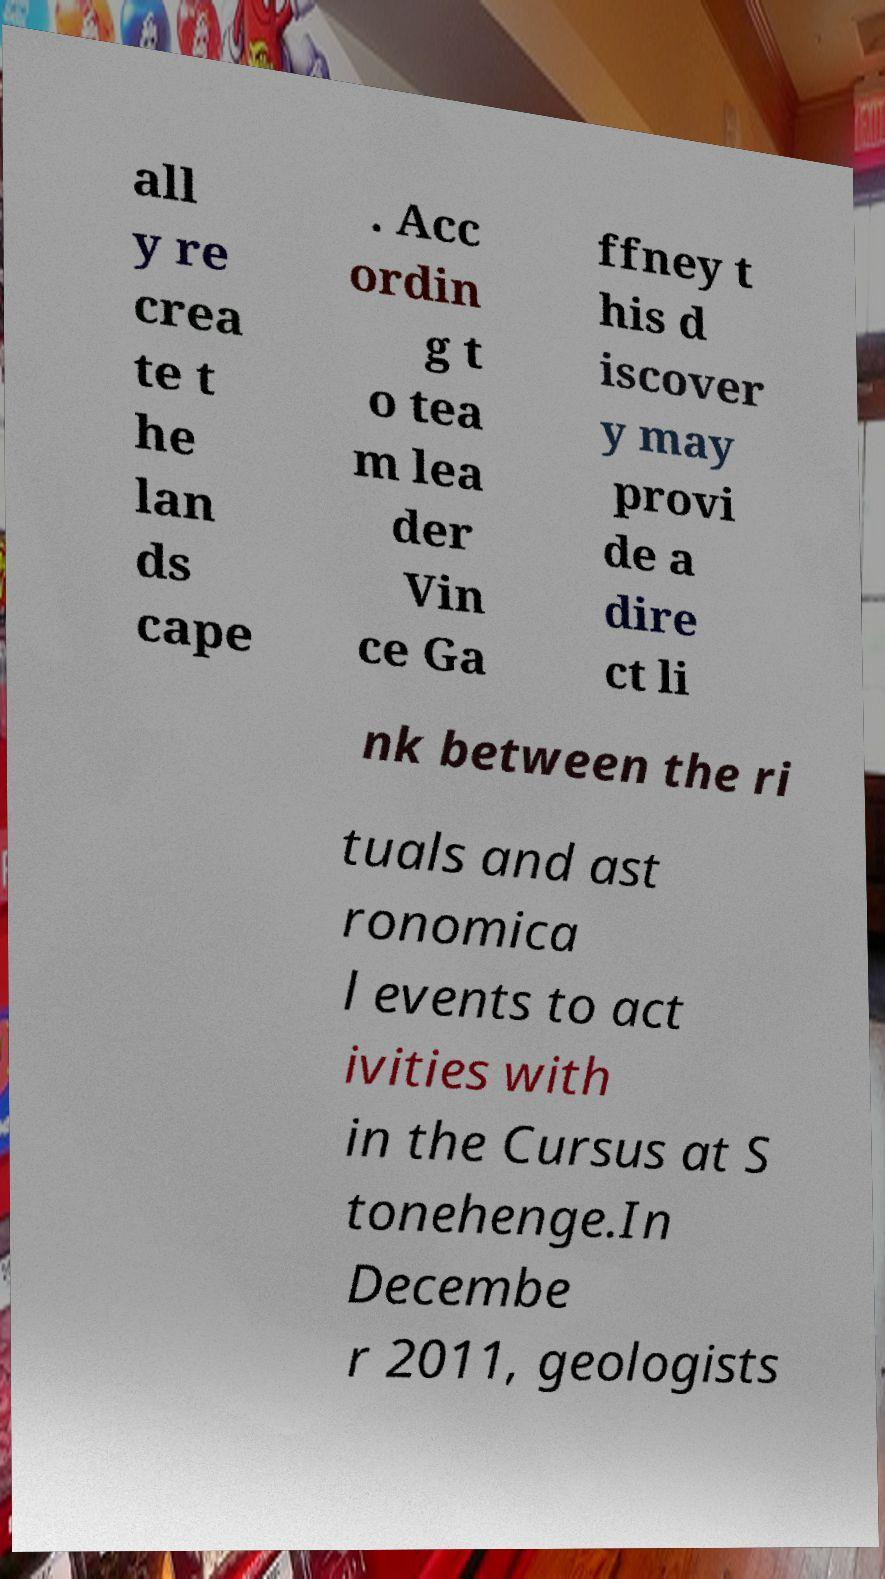Can you read and provide the text displayed in the image?This photo seems to have some interesting text. Can you extract and type it out for me? all y re crea te t he lan ds cape . Acc ordin g t o tea m lea der Vin ce Ga ffney t his d iscover y may provi de a dire ct li nk between the ri tuals and ast ronomica l events to act ivities with in the Cursus at S tonehenge.In Decembe r 2011, geologists 